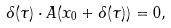Convert formula to latex. <formula><loc_0><loc_0><loc_500><loc_500>\delta ( \tau ) \cdot A ( x _ { 0 } + \delta ( \tau ) ) = 0 ,</formula> 